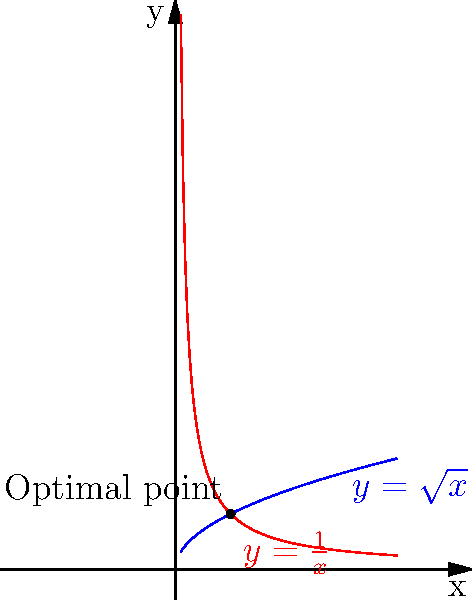Consider a column with a square cross-section. The area function of the cross-section is given by $A(x) = x$ and the perimeter function is $P(x) = 4\sqrt{x}$, where $x$ is the side length of the square. Using differential geometry principles, determine the optimal side length $x$ that minimizes the ratio of perimeter to area, $\frac{P(x)}{A(x)}$. What is this optimal ratio? To solve this optimization problem, we can follow these steps:

1) The ratio we want to minimize is:

   $$R(x) = \frac{P(x)}{A(x)} = \frac{4\sqrt{x}}{x} = \frac{4}{\sqrt{x}}$$

2) To find the minimum, we need to differentiate $R(x)$ with respect to $x$ and set it to zero:

   $$R'(x) = \frac{d}{dx}\left(\frac{4}{\sqrt{x}}\right) = -\frac{2}{\sqrt{x^3}}$$

3) Setting $R'(x) = 0$:

   $$-\frac{2}{\sqrt{x^3}} = 0$$

   This equation is never satisfied for positive $x$, which means there's no local minimum.

4) However, we can observe that as $x$ increases, $R(x)$ decreases monotonically. The minimum value of $R(x)$ occurs at the largest possible value of $x$.

5) In practice, the largest possible value of $x$ would be determined by other constraints (e.g., maximum allowable size). Without such constraints, we can consider the limit as $x$ approaches infinity:

   $$\lim_{x \to \infty} R(x) = \lim_{x \to \infty} \frac{4}{\sqrt{x}} = 0$$

6) However, for a practical answer, we need to consider the point where the area function ($y = x$) intersects with the perimeter function ($y = 4\sqrt{x}$). This occurs when:

   $$x = 4\sqrt{x}$$
   $$x^2 = 16x$$
   $$x = 16$$

7) At this point, the side length is 4, and the ratio $R(4) = \frac{4}{\sqrt{4}} = 2$.

This is the optimal practical ratio, balancing the perimeter and area functions.
Answer: The optimal ratio is 2, occurring when the side length is 4. 